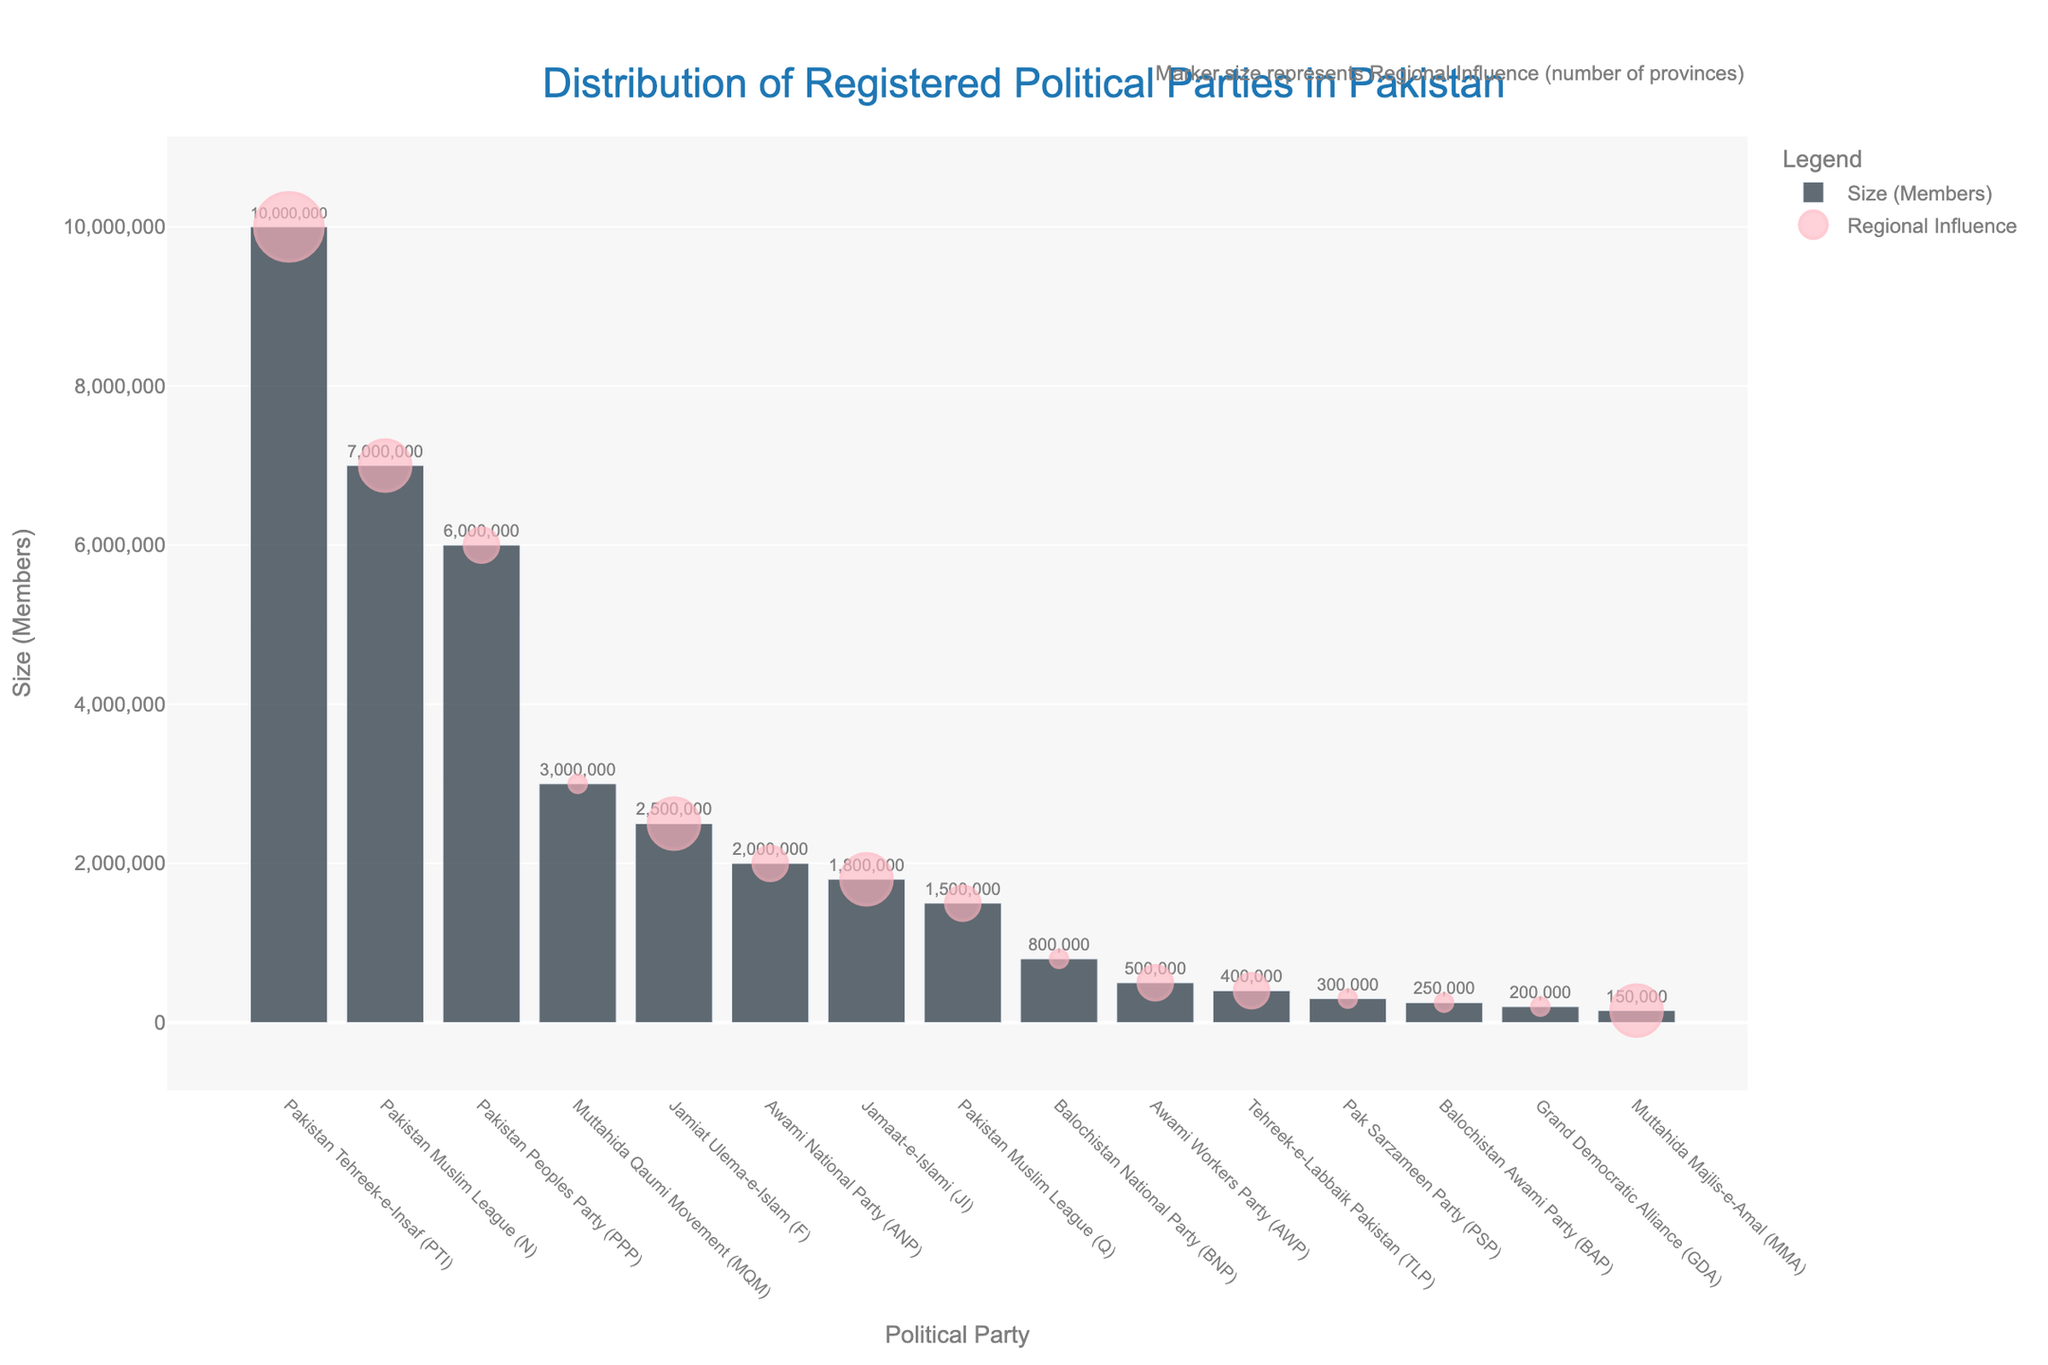What is the political party with the largest membership? The bar representing Pakistan Tehreek-e-Insaf (PTI) is the tallest, indicating that it has the largest membership.
Answer: Pakistan Tehreek-e-Insaf (PTI) Which party has the smallest regional influence? The markers representing Pak Sarzameen Party (PSP) and other parties like Balochistan Awami Party (BAP), and Grand Democratic Alliance (GDA) are the smallest, showing that these parties have the smallest regional influence (1 province).
Answer: Pak Sarzameen Party (PSP), Balochistan Awami Party (BAP), and Grand Democratic Alliance (GDA) How does the membership size of Pakistan Muslim League (N) compare to that of Jamiat Ulema-e-Islam (F)? The bar for Pakistan Muslim League (N) is significantly taller than the bar for Jamiat Ulema-e-Islam (F), indicating that Pakistan Muslim League (N) has a larger membership.
Answer: Pakistan Muslim League (N) has a larger membership What is the total membership size of the top three parties combined? The membership sizes for Pakistan Tehreek-e-Insaf (PTI), Pakistan Muslim League (N), and Pakistan Peoples Party (PPP) are 10,000,000, 7,000,000, and 6,000,000 respectively. Adding them together: 10,000,000 + 7,000,000 + 6,000,000 = 23,000,000.
Answer: 23,000,000 Which political party has influence in the most provinces? The markers for Pakistan Tehreek-e-Insaf (PTI) are the largest, indicating that it influences the most provinces (4).
Answer: Pakistan Tehreek-e-Insaf (PTI) Compare the membership size of Awami National Party (ANP) and Awami Workers Party (AWP). Which is larger? The bar for Awami National Party (ANP) is taller than that for Awami Workers Party (AWP), indicating that ANP has a larger membership size.
Answer: Awami National Party (ANP) What is the difference in membership size between Pakistan Peoples Party (PPP) and Muttahida Qaumi Movement (MQM)? The membership sizes for Pakistan Peoples Party (PPP) and Muttahida Qaumi Movement (MQM) are 6,000,000 and 3,000,000 respectively. The difference is 6,000,000 - 3,000,000 = 3,000,000.
Answer: 3,000,000 Which parties have a membership size of less than 500,000? The bars for Pak Sarzameen Party (PSP), Balochistan Awami Party (BAP), Grand Democratic Alliance (GDA), and Muttahida Majlis-e-Amal (MMA) are shorter and display values less than 500,000.
Answer: Pak Sarzameen Party (PSP), Balochistan Awami Party (BAP), Grand Democratic Alliance (GDA), Muttahida Majlis-e-Amal (MMA) Is there any party with a membership size of exactly 1,800,000? The bar for Jamaat-e-Islami (JI) displays a membership size of exactly 1,800,000.
Answer: Jamaat-e-Islami (JI) What is the average regional influence of the political parties? Summing the regional influences of all parties: 4 + 3 + 2 + 1 + 3 + 2 + 3 + 2 + 1 + 2 + 2 + 1 + 1 + 1 + 3 = 31. There are 15 parties in total, so the average is 31 / 15 = approximately 2.07 provinces.
Answer: Approximately 2.07 provinces 